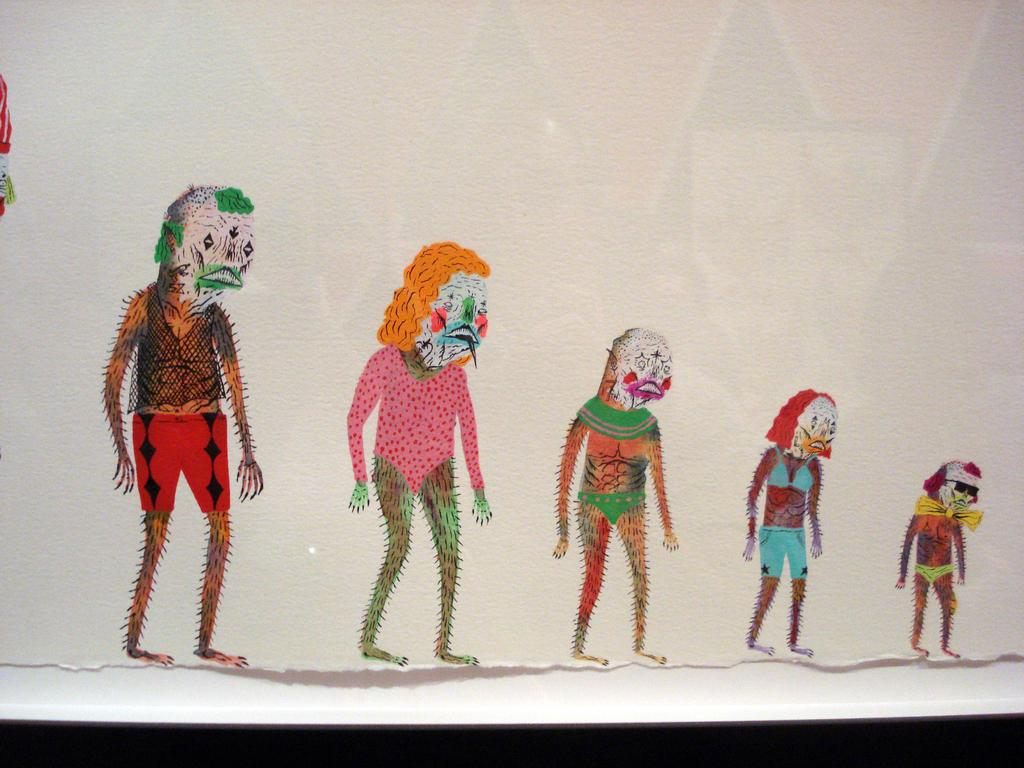What is depicted on the wall in the image? There is a wall painting in the image. What color is the wall on which the painting is displayed? The wall is white in color. Reasoning: Let' Let's think step by step in order to produce the conversation. We start by identifying the main subject in the image, which is the wall painting. Then, we expand the conversation to include the color of the wall, which is also mentioned in the provided facts. Each question is designed to elicit a specific detail about the image that is known from the given information. Absurd Question/Answer: What type of book can be seen on the wall painting in the image? There is no book present in the image, as it only features a wall painting on a white wall. 